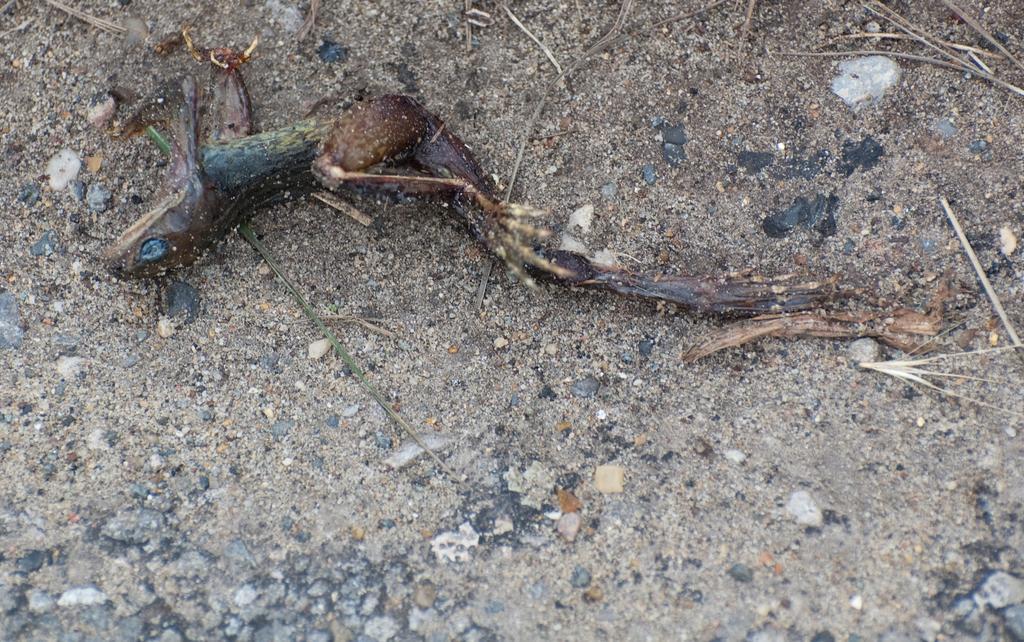Please provide a concise description of this image. In this image I can see the ground and a dead reptile which is green, brown and cream in color on the ground. 